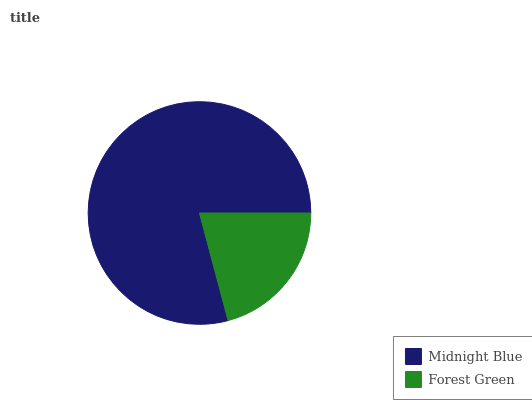Is Forest Green the minimum?
Answer yes or no. Yes. Is Midnight Blue the maximum?
Answer yes or no. Yes. Is Forest Green the maximum?
Answer yes or no. No. Is Midnight Blue greater than Forest Green?
Answer yes or no. Yes. Is Forest Green less than Midnight Blue?
Answer yes or no. Yes. Is Forest Green greater than Midnight Blue?
Answer yes or no. No. Is Midnight Blue less than Forest Green?
Answer yes or no. No. Is Midnight Blue the high median?
Answer yes or no. Yes. Is Forest Green the low median?
Answer yes or no. Yes. Is Forest Green the high median?
Answer yes or no. No. Is Midnight Blue the low median?
Answer yes or no. No. 